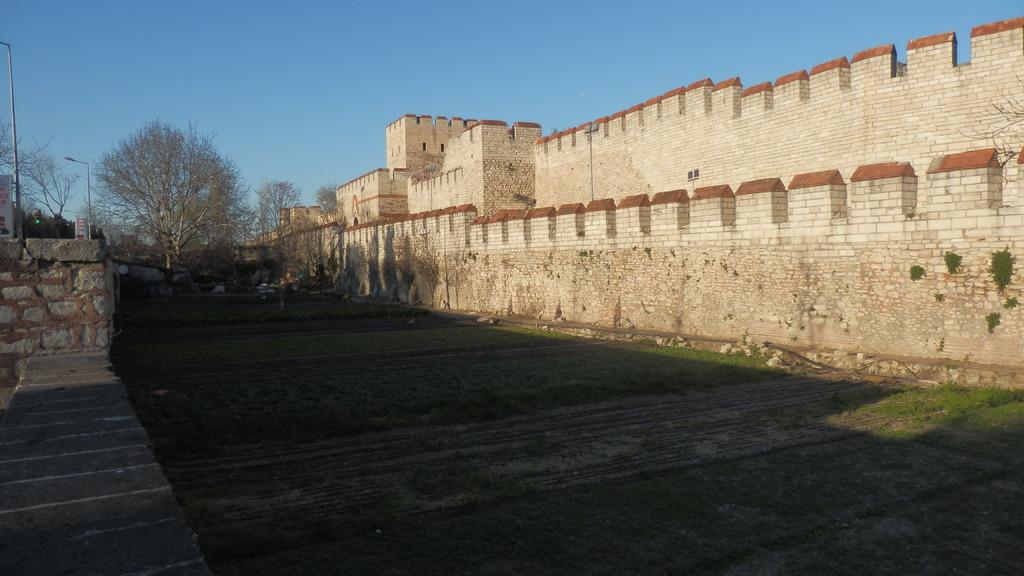What is located on the left and right sides of the image? There are walls on the left and right sides of the image. What can be seen in the middle of the image? There is grass and trees in the middle of the image. What is visible at the top of the image? The sky is visible at the top of the image. How does the hose contribute to the respect shown in the image? There is no hose present in the image, and therefore it cannot contribute to any respect shown. What type of noise can be heard coming from the trees in the image? There is no indication of any noise in the image, as it only features walls, grass, trees, and the sky. 